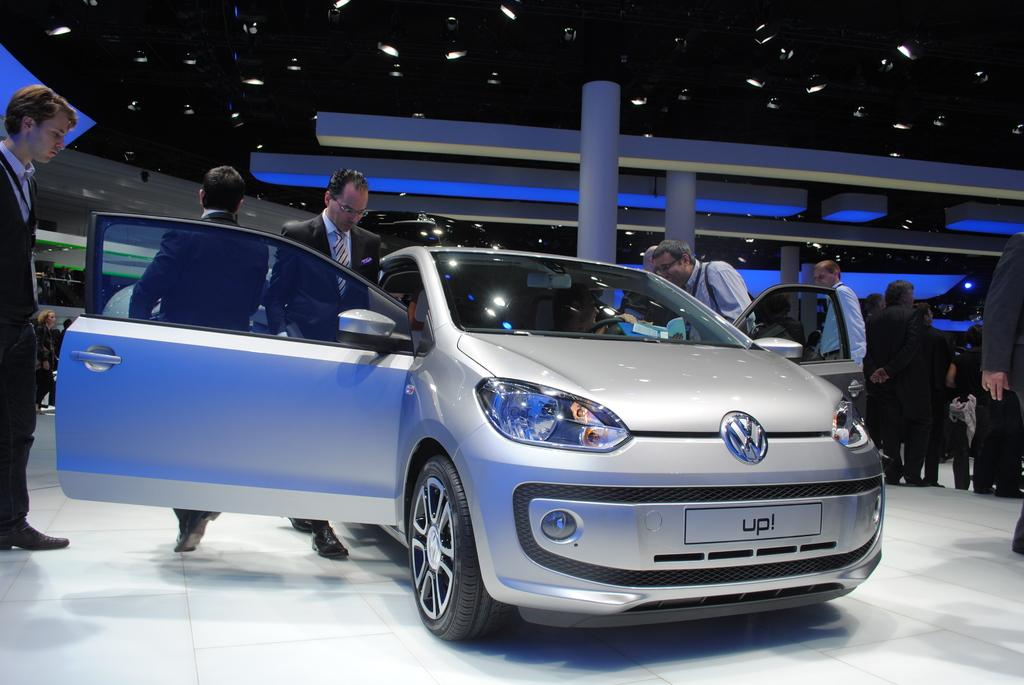What is the main subject of the image? There is a car in the image. Can you describe the lighting in the image? There are many lights in the image. How many people are visible in the image? There are many people in the image. What can be observed on the surface of the car? There are some reflections on the car. How much cabbage can be seen on the edge of the car in the image? There is no cabbage present on the edge of the car in the image. 